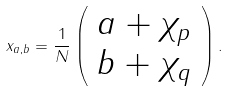<formula> <loc_0><loc_0><loc_500><loc_500>x _ { a , b } = \frac { 1 } { N } \left ( \begin{array} { c } a + \chi _ { p } \\ b + \chi _ { q } \end{array} \right ) .</formula> 